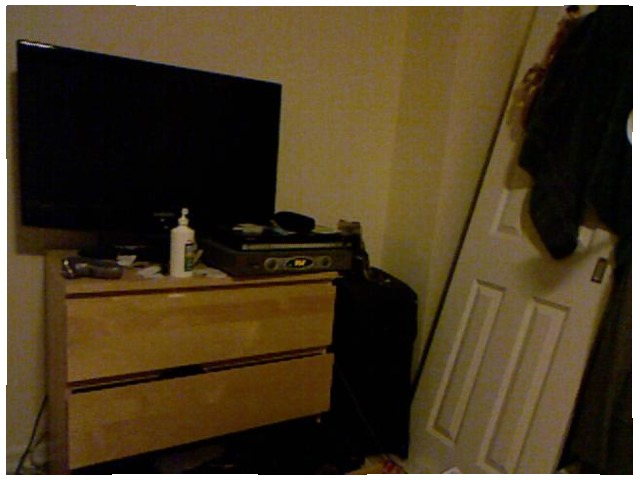<image>
Is there a cleaner liquid to the right of the dvd player? No. The cleaner liquid is not to the right of the dvd player. The horizontal positioning shows a different relationship. Is there a tv in the wall? No. The tv is not contained within the wall. These objects have a different spatial relationship. 